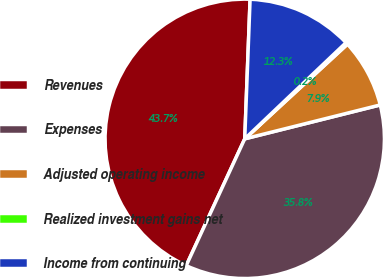Convert chart. <chart><loc_0><loc_0><loc_500><loc_500><pie_chart><fcel>Revenues<fcel>Expenses<fcel>Adjusted operating income<fcel>Realized investment gains net<fcel>Income from continuing<nl><fcel>43.73%<fcel>35.79%<fcel>7.95%<fcel>0.24%<fcel>12.3%<nl></chart> 